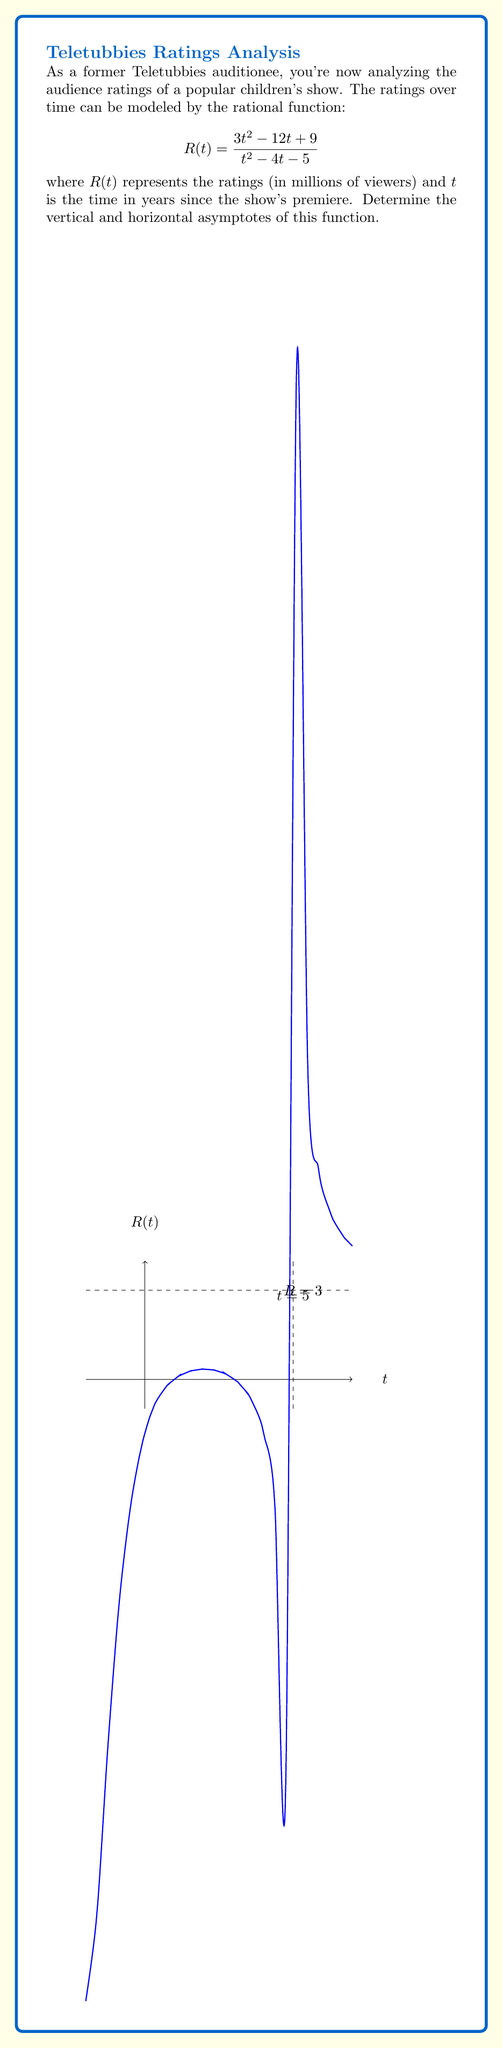Can you solve this math problem? Let's approach this step-by-step:

1) To find the vertical asymptotes, we need to find the values of $t$ that make the denominator zero:

   $$t^2 - 4t - 5 = 0$$
   $$(t-5)(t+1) = 0$$
   $$t = 5 \text{ or } t = -1$$

   So, there are vertical asymptotes at $t = 5$ and $t = -1$.

2) To find the horizontal asymptote, we compare the degrees of the numerator and denominator:

   - Numerator degree: 2
   - Denominator degree: 2

   When these are equal, the horizontal asymptote is the ratio of the leading coefficients:

   $$\lim_{t \to \infty} \frac{3t^2}{t^2} = 3$$

   Therefore, the horizontal asymptote is at $R = 3$.

3) We can confirm this by dividing the numerator by the denominator:

   $$\frac{3t^2 - 12t + 9}{t^2 - 4t - 5} = 3 + \frac{12t - 6}{t^2 - 4t - 5}$$

   As $t$ approaches infinity, the fraction $\frac{12t - 6}{t^2 - 4t - 5}$ approaches 0, leaving us with 3.
Answer: Vertical asymptotes: $t = 5$, $t = -1$; Horizontal asymptote: $R = 3$ 